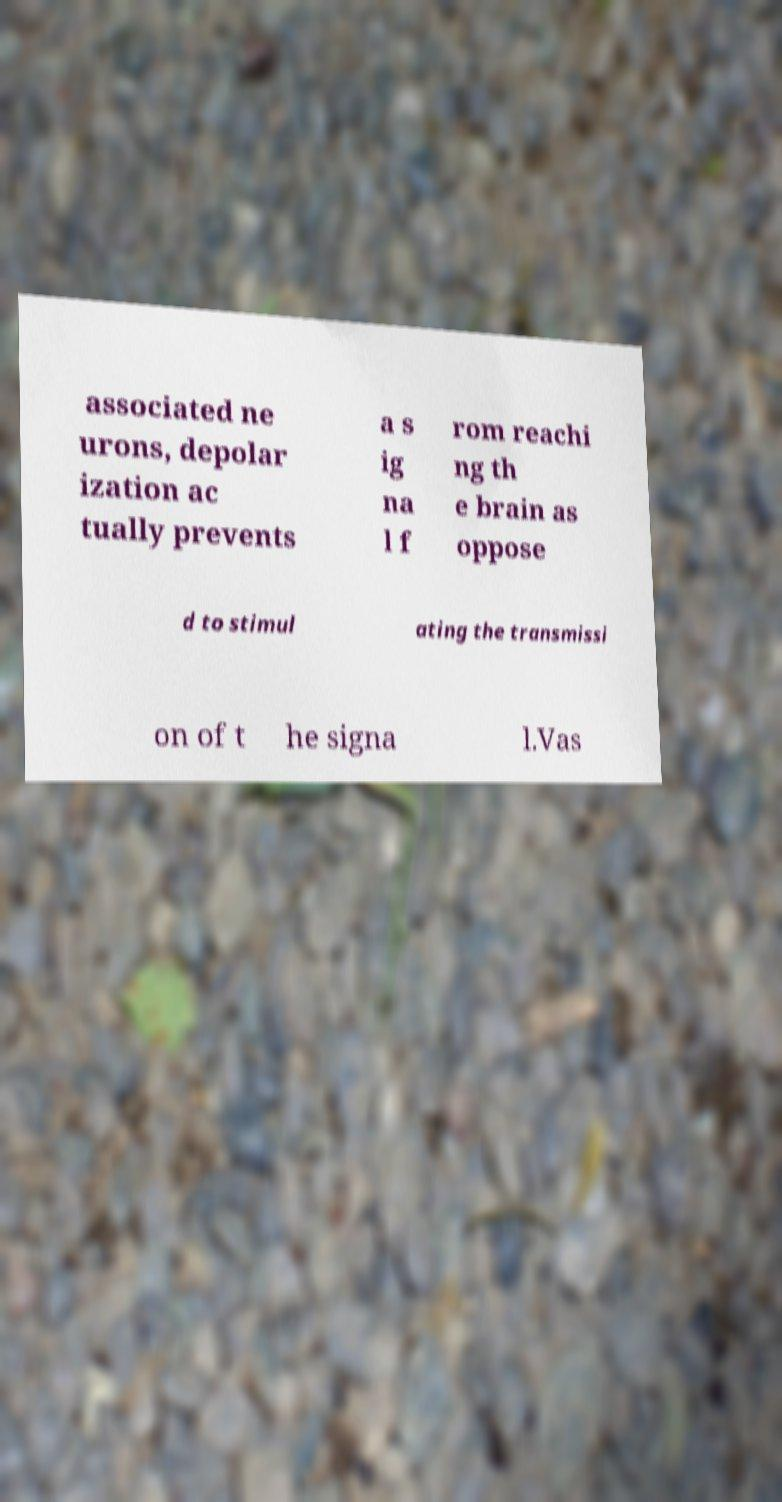Can you accurately transcribe the text from the provided image for me? associated ne urons, depolar ization ac tually prevents a s ig na l f rom reachi ng th e brain as oppose d to stimul ating the transmissi on of t he signa l.Vas 